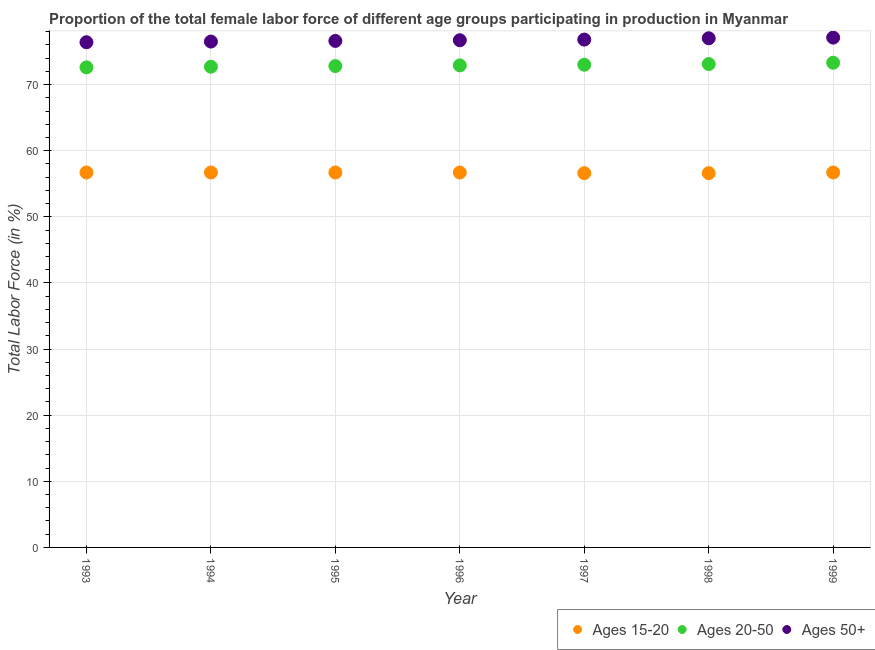How many different coloured dotlines are there?
Your answer should be very brief. 3. What is the percentage of female labor force within the age group 15-20 in 1996?
Provide a succinct answer. 56.7. Across all years, what is the maximum percentage of female labor force above age 50?
Make the answer very short. 77.1. Across all years, what is the minimum percentage of female labor force within the age group 20-50?
Offer a very short reply. 72.6. In which year was the percentage of female labor force above age 50 maximum?
Your answer should be very brief. 1999. In which year was the percentage of female labor force above age 50 minimum?
Provide a short and direct response. 1993. What is the total percentage of female labor force within the age group 20-50 in the graph?
Make the answer very short. 510.4. What is the difference between the percentage of female labor force within the age group 20-50 in 1996 and that in 1998?
Your response must be concise. -0.2. What is the difference between the percentage of female labor force within the age group 15-20 in 1997 and the percentage of female labor force above age 50 in 1999?
Provide a succinct answer. -20.5. What is the average percentage of female labor force within the age group 20-50 per year?
Your response must be concise. 72.91. In the year 1994, what is the difference between the percentage of female labor force within the age group 20-50 and percentage of female labor force within the age group 15-20?
Your response must be concise. 16. In how many years, is the percentage of female labor force above age 50 greater than 32 %?
Offer a very short reply. 7. What is the ratio of the percentage of female labor force above age 50 in 1993 to that in 1997?
Your answer should be compact. 0.99. Is the difference between the percentage of female labor force within the age group 15-20 in 1993 and 1997 greater than the difference between the percentage of female labor force above age 50 in 1993 and 1997?
Offer a terse response. Yes. What is the difference between the highest and the second highest percentage of female labor force within the age group 20-50?
Make the answer very short. 0.2. What is the difference between the highest and the lowest percentage of female labor force within the age group 20-50?
Offer a terse response. 0.7. In how many years, is the percentage of female labor force above age 50 greater than the average percentage of female labor force above age 50 taken over all years?
Offer a very short reply. 3. Is the sum of the percentage of female labor force within the age group 15-20 in 1994 and 1999 greater than the maximum percentage of female labor force within the age group 20-50 across all years?
Give a very brief answer. Yes. Is it the case that in every year, the sum of the percentage of female labor force within the age group 15-20 and percentage of female labor force within the age group 20-50 is greater than the percentage of female labor force above age 50?
Offer a terse response. Yes. How many dotlines are there?
Offer a terse response. 3. How many years are there in the graph?
Make the answer very short. 7. Are the values on the major ticks of Y-axis written in scientific E-notation?
Give a very brief answer. No. Does the graph contain any zero values?
Your response must be concise. No. Does the graph contain grids?
Make the answer very short. Yes. What is the title of the graph?
Provide a short and direct response. Proportion of the total female labor force of different age groups participating in production in Myanmar. What is the label or title of the X-axis?
Offer a very short reply. Year. What is the Total Labor Force (in %) of Ages 15-20 in 1993?
Provide a short and direct response. 56.7. What is the Total Labor Force (in %) of Ages 20-50 in 1993?
Provide a succinct answer. 72.6. What is the Total Labor Force (in %) of Ages 50+ in 1993?
Give a very brief answer. 76.4. What is the Total Labor Force (in %) of Ages 15-20 in 1994?
Make the answer very short. 56.7. What is the Total Labor Force (in %) in Ages 20-50 in 1994?
Make the answer very short. 72.7. What is the Total Labor Force (in %) in Ages 50+ in 1994?
Ensure brevity in your answer.  76.5. What is the Total Labor Force (in %) in Ages 15-20 in 1995?
Offer a very short reply. 56.7. What is the Total Labor Force (in %) in Ages 20-50 in 1995?
Your answer should be very brief. 72.8. What is the Total Labor Force (in %) in Ages 50+ in 1995?
Keep it short and to the point. 76.6. What is the Total Labor Force (in %) of Ages 15-20 in 1996?
Give a very brief answer. 56.7. What is the Total Labor Force (in %) in Ages 20-50 in 1996?
Keep it short and to the point. 72.9. What is the Total Labor Force (in %) of Ages 50+ in 1996?
Your response must be concise. 76.7. What is the Total Labor Force (in %) of Ages 15-20 in 1997?
Offer a very short reply. 56.6. What is the Total Labor Force (in %) in Ages 20-50 in 1997?
Ensure brevity in your answer.  73. What is the Total Labor Force (in %) in Ages 50+ in 1997?
Ensure brevity in your answer.  76.8. What is the Total Labor Force (in %) in Ages 15-20 in 1998?
Offer a very short reply. 56.6. What is the Total Labor Force (in %) of Ages 20-50 in 1998?
Your answer should be very brief. 73.1. What is the Total Labor Force (in %) of Ages 50+ in 1998?
Your response must be concise. 77. What is the Total Labor Force (in %) in Ages 15-20 in 1999?
Offer a very short reply. 56.7. What is the Total Labor Force (in %) of Ages 20-50 in 1999?
Give a very brief answer. 73.3. What is the Total Labor Force (in %) in Ages 50+ in 1999?
Your answer should be compact. 77.1. Across all years, what is the maximum Total Labor Force (in %) of Ages 15-20?
Ensure brevity in your answer.  56.7. Across all years, what is the maximum Total Labor Force (in %) in Ages 20-50?
Ensure brevity in your answer.  73.3. Across all years, what is the maximum Total Labor Force (in %) of Ages 50+?
Offer a very short reply. 77.1. Across all years, what is the minimum Total Labor Force (in %) of Ages 15-20?
Offer a very short reply. 56.6. Across all years, what is the minimum Total Labor Force (in %) of Ages 20-50?
Offer a terse response. 72.6. Across all years, what is the minimum Total Labor Force (in %) in Ages 50+?
Your answer should be very brief. 76.4. What is the total Total Labor Force (in %) in Ages 15-20 in the graph?
Provide a succinct answer. 396.7. What is the total Total Labor Force (in %) of Ages 20-50 in the graph?
Provide a short and direct response. 510.4. What is the total Total Labor Force (in %) in Ages 50+ in the graph?
Offer a terse response. 537.1. What is the difference between the Total Labor Force (in %) of Ages 15-20 in 1993 and that in 1994?
Give a very brief answer. 0. What is the difference between the Total Labor Force (in %) in Ages 20-50 in 1993 and that in 1994?
Your answer should be compact. -0.1. What is the difference between the Total Labor Force (in %) of Ages 15-20 in 1993 and that in 1995?
Your answer should be compact. 0. What is the difference between the Total Labor Force (in %) in Ages 20-50 in 1993 and that in 1995?
Offer a very short reply. -0.2. What is the difference between the Total Labor Force (in %) of Ages 15-20 in 1993 and that in 1997?
Offer a terse response. 0.1. What is the difference between the Total Labor Force (in %) in Ages 20-50 in 1993 and that in 1997?
Your answer should be compact. -0.4. What is the difference between the Total Labor Force (in %) in Ages 15-20 in 1993 and that in 1998?
Offer a very short reply. 0.1. What is the difference between the Total Labor Force (in %) of Ages 20-50 in 1993 and that in 1998?
Provide a short and direct response. -0.5. What is the difference between the Total Labor Force (in %) of Ages 50+ in 1993 and that in 1998?
Your response must be concise. -0.6. What is the difference between the Total Labor Force (in %) in Ages 20-50 in 1993 and that in 1999?
Offer a terse response. -0.7. What is the difference between the Total Labor Force (in %) in Ages 15-20 in 1994 and that in 1995?
Provide a succinct answer. 0. What is the difference between the Total Labor Force (in %) in Ages 20-50 in 1994 and that in 1995?
Offer a terse response. -0.1. What is the difference between the Total Labor Force (in %) in Ages 20-50 in 1994 and that in 1997?
Your answer should be compact. -0.3. What is the difference between the Total Labor Force (in %) of Ages 50+ in 1994 and that in 1997?
Give a very brief answer. -0.3. What is the difference between the Total Labor Force (in %) of Ages 50+ in 1994 and that in 1998?
Keep it short and to the point. -0.5. What is the difference between the Total Labor Force (in %) in Ages 50+ in 1994 and that in 1999?
Provide a short and direct response. -0.6. What is the difference between the Total Labor Force (in %) of Ages 15-20 in 1995 and that in 1996?
Provide a succinct answer. 0. What is the difference between the Total Labor Force (in %) of Ages 20-50 in 1995 and that in 1996?
Keep it short and to the point. -0.1. What is the difference between the Total Labor Force (in %) of Ages 50+ in 1995 and that in 1996?
Offer a terse response. -0.1. What is the difference between the Total Labor Force (in %) in Ages 20-50 in 1995 and that in 1997?
Your response must be concise. -0.2. What is the difference between the Total Labor Force (in %) in Ages 20-50 in 1995 and that in 1998?
Give a very brief answer. -0.3. What is the difference between the Total Labor Force (in %) in Ages 15-20 in 1995 and that in 1999?
Ensure brevity in your answer.  0. What is the difference between the Total Labor Force (in %) of Ages 20-50 in 1995 and that in 1999?
Make the answer very short. -0.5. What is the difference between the Total Labor Force (in %) of Ages 15-20 in 1996 and that in 1997?
Provide a succinct answer. 0.1. What is the difference between the Total Labor Force (in %) of Ages 50+ in 1996 and that in 1997?
Offer a terse response. -0.1. What is the difference between the Total Labor Force (in %) in Ages 50+ in 1996 and that in 1998?
Your answer should be very brief. -0.3. What is the difference between the Total Labor Force (in %) in Ages 50+ in 1996 and that in 1999?
Your response must be concise. -0.4. What is the difference between the Total Labor Force (in %) in Ages 15-20 in 1997 and that in 1998?
Provide a short and direct response. 0. What is the difference between the Total Labor Force (in %) of Ages 20-50 in 1997 and that in 1998?
Your response must be concise. -0.1. What is the difference between the Total Labor Force (in %) of Ages 50+ in 1997 and that in 1998?
Your answer should be very brief. -0.2. What is the difference between the Total Labor Force (in %) in Ages 20-50 in 1997 and that in 1999?
Offer a very short reply. -0.3. What is the difference between the Total Labor Force (in %) in Ages 50+ in 1997 and that in 1999?
Offer a very short reply. -0.3. What is the difference between the Total Labor Force (in %) of Ages 15-20 in 1998 and that in 1999?
Your response must be concise. -0.1. What is the difference between the Total Labor Force (in %) in Ages 20-50 in 1998 and that in 1999?
Provide a succinct answer. -0.2. What is the difference between the Total Labor Force (in %) in Ages 50+ in 1998 and that in 1999?
Your answer should be compact. -0.1. What is the difference between the Total Labor Force (in %) in Ages 15-20 in 1993 and the Total Labor Force (in %) in Ages 20-50 in 1994?
Your answer should be compact. -16. What is the difference between the Total Labor Force (in %) in Ages 15-20 in 1993 and the Total Labor Force (in %) in Ages 50+ in 1994?
Provide a short and direct response. -19.8. What is the difference between the Total Labor Force (in %) of Ages 15-20 in 1993 and the Total Labor Force (in %) of Ages 20-50 in 1995?
Provide a short and direct response. -16.1. What is the difference between the Total Labor Force (in %) in Ages 15-20 in 1993 and the Total Labor Force (in %) in Ages 50+ in 1995?
Your answer should be very brief. -19.9. What is the difference between the Total Labor Force (in %) in Ages 15-20 in 1993 and the Total Labor Force (in %) in Ages 20-50 in 1996?
Give a very brief answer. -16.2. What is the difference between the Total Labor Force (in %) in Ages 15-20 in 1993 and the Total Labor Force (in %) in Ages 50+ in 1996?
Give a very brief answer. -20. What is the difference between the Total Labor Force (in %) in Ages 15-20 in 1993 and the Total Labor Force (in %) in Ages 20-50 in 1997?
Offer a terse response. -16.3. What is the difference between the Total Labor Force (in %) in Ages 15-20 in 1993 and the Total Labor Force (in %) in Ages 50+ in 1997?
Provide a short and direct response. -20.1. What is the difference between the Total Labor Force (in %) in Ages 20-50 in 1993 and the Total Labor Force (in %) in Ages 50+ in 1997?
Give a very brief answer. -4.2. What is the difference between the Total Labor Force (in %) of Ages 15-20 in 1993 and the Total Labor Force (in %) of Ages 20-50 in 1998?
Give a very brief answer. -16.4. What is the difference between the Total Labor Force (in %) of Ages 15-20 in 1993 and the Total Labor Force (in %) of Ages 50+ in 1998?
Keep it short and to the point. -20.3. What is the difference between the Total Labor Force (in %) in Ages 15-20 in 1993 and the Total Labor Force (in %) in Ages 20-50 in 1999?
Offer a terse response. -16.6. What is the difference between the Total Labor Force (in %) of Ages 15-20 in 1993 and the Total Labor Force (in %) of Ages 50+ in 1999?
Offer a very short reply. -20.4. What is the difference between the Total Labor Force (in %) of Ages 15-20 in 1994 and the Total Labor Force (in %) of Ages 20-50 in 1995?
Provide a succinct answer. -16.1. What is the difference between the Total Labor Force (in %) of Ages 15-20 in 1994 and the Total Labor Force (in %) of Ages 50+ in 1995?
Offer a very short reply. -19.9. What is the difference between the Total Labor Force (in %) of Ages 20-50 in 1994 and the Total Labor Force (in %) of Ages 50+ in 1995?
Your answer should be very brief. -3.9. What is the difference between the Total Labor Force (in %) in Ages 15-20 in 1994 and the Total Labor Force (in %) in Ages 20-50 in 1996?
Ensure brevity in your answer.  -16.2. What is the difference between the Total Labor Force (in %) in Ages 15-20 in 1994 and the Total Labor Force (in %) in Ages 20-50 in 1997?
Your response must be concise. -16.3. What is the difference between the Total Labor Force (in %) of Ages 15-20 in 1994 and the Total Labor Force (in %) of Ages 50+ in 1997?
Give a very brief answer. -20.1. What is the difference between the Total Labor Force (in %) in Ages 20-50 in 1994 and the Total Labor Force (in %) in Ages 50+ in 1997?
Offer a very short reply. -4.1. What is the difference between the Total Labor Force (in %) in Ages 15-20 in 1994 and the Total Labor Force (in %) in Ages 20-50 in 1998?
Give a very brief answer. -16.4. What is the difference between the Total Labor Force (in %) of Ages 15-20 in 1994 and the Total Labor Force (in %) of Ages 50+ in 1998?
Provide a succinct answer. -20.3. What is the difference between the Total Labor Force (in %) in Ages 20-50 in 1994 and the Total Labor Force (in %) in Ages 50+ in 1998?
Ensure brevity in your answer.  -4.3. What is the difference between the Total Labor Force (in %) of Ages 15-20 in 1994 and the Total Labor Force (in %) of Ages 20-50 in 1999?
Offer a very short reply. -16.6. What is the difference between the Total Labor Force (in %) in Ages 15-20 in 1994 and the Total Labor Force (in %) in Ages 50+ in 1999?
Keep it short and to the point. -20.4. What is the difference between the Total Labor Force (in %) of Ages 15-20 in 1995 and the Total Labor Force (in %) of Ages 20-50 in 1996?
Provide a succinct answer. -16.2. What is the difference between the Total Labor Force (in %) in Ages 15-20 in 1995 and the Total Labor Force (in %) in Ages 50+ in 1996?
Provide a succinct answer. -20. What is the difference between the Total Labor Force (in %) in Ages 15-20 in 1995 and the Total Labor Force (in %) in Ages 20-50 in 1997?
Your answer should be very brief. -16.3. What is the difference between the Total Labor Force (in %) of Ages 15-20 in 1995 and the Total Labor Force (in %) of Ages 50+ in 1997?
Your answer should be very brief. -20.1. What is the difference between the Total Labor Force (in %) in Ages 15-20 in 1995 and the Total Labor Force (in %) in Ages 20-50 in 1998?
Make the answer very short. -16.4. What is the difference between the Total Labor Force (in %) in Ages 15-20 in 1995 and the Total Labor Force (in %) in Ages 50+ in 1998?
Give a very brief answer. -20.3. What is the difference between the Total Labor Force (in %) of Ages 15-20 in 1995 and the Total Labor Force (in %) of Ages 20-50 in 1999?
Your answer should be compact. -16.6. What is the difference between the Total Labor Force (in %) of Ages 15-20 in 1995 and the Total Labor Force (in %) of Ages 50+ in 1999?
Ensure brevity in your answer.  -20.4. What is the difference between the Total Labor Force (in %) in Ages 20-50 in 1995 and the Total Labor Force (in %) in Ages 50+ in 1999?
Offer a terse response. -4.3. What is the difference between the Total Labor Force (in %) of Ages 15-20 in 1996 and the Total Labor Force (in %) of Ages 20-50 in 1997?
Give a very brief answer. -16.3. What is the difference between the Total Labor Force (in %) of Ages 15-20 in 1996 and the Total Labor Force (in %) of Ages 50+ in 1997?
Provide a succinct answer. -20.1. What is the difference between the Total Labor Force (in %) in Ages 15-20 in 1996 and the Total Labor Force (in %) in Ages 20-50 in 1998?
Provide a short and direct response. -16.4. What is the difference between the Total Labor Force (in %) in Ages 15-20 in 1996 and the Total Labor Force (in %) in Ages 50+ in 1998?
Ensure brevity in your answer.  -20.3. What is the difference between the Total Labor Force (in %) of Ages 15-20 in 1996 and the Total Labor Force (in %) of Ages 20-50 in 1999?
Your response must be concise. -16.6. What is the difference between the Total Labor Force (in %) of Ages 15-20 in 1996 and the Total Labor Force (in %) of Ages 50+ in 1999?
Offer a terse response. -20.4. What is the difference between the Total Labor Force (in %) of Ages 20-50 in 1996 and the Total Labor Force (in %) of Ages 50+ in 1999?
Ensure brevity in your answer.  -4.2. What is the difference between the Total Labor Force (in %) of Ages 15-20 in 1997 and the Total Labor Force (in %) of Ages 20-50 in 1998?
Keep it short and to the point. -16.5. What is the difference between the Total Labor Force (in %) in Ages 15-20 in 1997 and the Total Labor Force (in %) in Ages 50+ in 1998?
Make the answer very short. -20.4. What is the difference between the Total Labor Force (in %) of Ages 15-20 in 1997 and the Total Labor Force (in %) of Ages 20-50 in 1999?
Give a very brief answer. -16.7. What is the difference between the Total Labor Force (in %) in Ages 15-20 in 1997 and the Total Labor Force (in %) in Ages 50+ in 1999?
Your answer should be compact. -20.5. What is the difference between the Total Labor Force (in %) of Ages 20-50 in 1997 and the Total Labor Force (in %) of Ages 50+ in 1999?
Your response must be concise. -4.1. What is the difference between the Total Labor Force (in %) in Ages 15-20 in 1998 and the Total Labor Force (in %) in Ages 20-50 in 1999?
Provide a short and direct response. -16.7. What is the difference between the Total Labor Force (in %) of Ages 15-20 in 1998 and the Total Labor Force (in %) of Ages 50+ in 1999?
Ensure brevity in your answer.  -20.5. What is the average Total Labor Force (in %) in Ages 15-20 per year?
Provide a succinct answer. 56.67. What is the average Total Labor Force (in %) of Ages 20-50 per year?
Make the answer very short. 72.91. What is the average Total Labor Force (in %) of Ages 50+ per year?
Your answer should be very brief. 76.73. In the year 1993, what is the difference between the Total Labor Force (in %) of Ages 15-20 and Total Labor Force (in %) of Ages 20-50?
Offer a very short reply. -15.9. In the year 1993, what is the difference between the Total Labor Force (in %) of Ages 15-20 and Total Labor Force (in %) of Ages 50+?
Offer a terse response. -19.7. In the year 1993, what is the difference between the Total Labor Force (in %) of Ages 20-50 and Total Labor Force (in %) of Ages 50+?
Your answer should be compact. -3.8. In the year 1994, what is the difference between the Total Labor Force (in %) in Ages 15-20 and Total Labor Force (in %) in Ages 20-50?
Your response must be concise. -16. In the year 1994, what is the difference between the Total Labor Force (in %) in Ages 15-20 and Total Labor Force (in %) in Ages 50+?
Make the answer very short. -19.8. In the year 1995, what is the difference between the Total Labor Force (in %) of Ages 15-20 and Total Labor Force (in %) of Ages 20-50?
Ensure brevity in your answer.  -16.1. In the year 1995, what is the difference between the Total Labor Force (in %) of Ages 15-20 and Total Labor Force (in %) of Ages 50+?
Provide a succinct answer. -19.9. In the year 1995, what is the difference between the Total Labor Force (in %) of Ages 20-50 and Total Labor Force (in %) of Ages 50+?
Your response must be concise. -3.8. In the year 1996, what is the difference between the Total Labor Force (in %) of Ages 15-20 and Total Labor Force (in %) of Ages 20-50?
Your response must be concise. -16.2. In the year 1997, what is the difference between the Total Labor Force (in %) in Ages 15-20 and Total Labor Force (in %) in Ages 20-50?
Ensure brevity in your answer.  -16.4. In the year 1997, what is the difference between the Total Labor Force (in %) of Ages 15-20 and Total Labor Force (in %) of Ages 50+?
Offer a very short reply. -20.2. In the year 1998, what is the difference between the Total Labor Force (in %) in Ages 15-20 and Total Labor Force (in %) in Ages 20-50?
Offer a terse response. -16.5. In the year 1998, what is the difference between the Total Labor Force (in %) of Ages 15-20 and Total Labor Force (in %) of Ages 50+?
Offer a terse response. -20.4. In the year 1999, what is the difference between the Total Labor Force (in %) of Ages 15-20 and Total Labor Force (in %) of Ages 20-50?
Give a very brief answer. -16.6. In the year 1999, what is the difference between the Total Labor Force (in %) in Ages 15-20 and Total Labor Force (in %) in Ages 50+?
Provide a short and direct response. -20.4. In the year 1999, what is the difference between the Total Labor Force (in %) in Ages 20-50 and Total Labor Force (in %) in Ages 50+?
Make the answer very short. -3.8. What is the ratio of the Total Labor Force (in %) of Ages 20-50 in 1993 to that in 1994?
Your answer should be very brief. 1. What is the ratio of the Total Labor Force (in %) in Ages 50+ in 1993 to that in 1994?
Provide a succinct answer. 1. What is the ratio of the Total Labor Force (in %) of Ages 15-20 in 1993 to that in 1995?
Keep it short and to the point. 1. What is the ratio of the Total Labor Force (in %) in Ages 20-50 in 1993 to that in 1996?
Make the answer very short. 1. What is the ratio of the Total Labor Force (in %) of Ages 50+ in 1993 to that in 1996?
Make the answer very short. 1. What is the ratio of the Total Labor Force (in %) in Ages 15-20 in 1993 to that in 1999?
Provide a succinct answer. 1. What is the ratio of the Total Labor Force (in %) of Ages 20-50 in 1993 to that in 1999?
Your answer should be compact. 0.99. What is the ratio of the Total Labor Force (in %) in Ages 50+ in 1993 to that in 1999?
Ensure brevity in your answer.  0.99. What is the ratio of the Total Labor Force (in %) of Ages 20-50 in 1994 to that in 1995?
Provide a short and direct response. 1. What is the ratio of the Total Labor Force (in %) in Ages 50+ in 1994 to that in 1995?
Your answer should be very brief. 1. What is the ratio of the Total Labor Force (in %) in Ages 15-20 in 1994 to that in 1996?
Offer a terse response. 1. What is the ratio of the Total Labor Force (in %) of Ages 50+ in 1994 to that in 1996?
Provide a succinct answer. 1. What is the ratio of the Total Labor Force (in %) of Ages 20-50 in 1994 to that in 1997?
Your response must be concise. 1. What is the ratio of the Total Labor Force (in %) in Ages 20-50 in 1994 to that in 1998?
Your answer should be very brief. 0.99. What is the ratio of the Total Labor Force (in %) of Ages 50+ in 1994 to that in 1998?
Your response must be concise. 0.99. What is the ratio of the Total Labor Force (in %) of Ages 15-20 in 1995 to that in 1996?
Provide a short and direct response. 1. What is the ratio of the Total Labor Force (in %) of Ages 50+ in 1995 to that in 1996?
Your response must be concise. 1. What is the ratio of the Total Labor Force (in %) in Ages 15-20 in 1995 to that in 1997?
Offer a very short reply. 1. What is the ratio of the Total Labor Force (in %) in Ages 50+ in 1995 to that in 1997?
Ensure brevity in your answer.  1. What is the ratio of the Total Labor Force (in %) of Ages 20-50 in 1995 to that in 1999?
Give a very brief answer. 0.99. What is the ratio of the Total Labor Force (in %) in Ages 20-50 in 1996 to that in 1997?
Provide a short and direct response. 1. What is the ratio of the Total Labor Force (in %) of Ages 50+ in 1996 to that in 1997?
Provide a succinct answer. 1. What is the ratio of the Total Labor Force (in %) of Ages 15-20 in 1996 to that in 1998?
Provide a short and direct response. 1. What is the ratio of the Total Labor Force (in %) in Ages 15-20 in 1996 to that in 1999?
Your answer should be compact. 1. What is the ratio of the Total Labor Force (in %) of Ages 50+ in 1997 to that in 1999?
Offer a very short reply. 1. What is the ratio of the Total Labor Force (in %) in Ages 15-20 in 1998 to that in 1999?
Offer a terse response. 1. What is the ratio of the Total Labor Force (in %) in Ages 20-50 in 1998 to that in 1999?
Make the answer very short. 1. What is the difference between the highest and the second highest Total Labor Force (in %) of Ages 15-20?
Provide a short and direct response. 0. What is the difference between the highest and the second highest Total Labor Force (in %) in Ages 20-50?
Make the answer very short. 0.2. What is the difference between the highest and the lowest Total Labor Force (in %) in Ages 20-50?
Provide a succinct answer. 0.7. What is the difference between the highest and the lowest Total Labor Force (in %) in Ages 50+?
Your answer should be very brief. 0.7. 